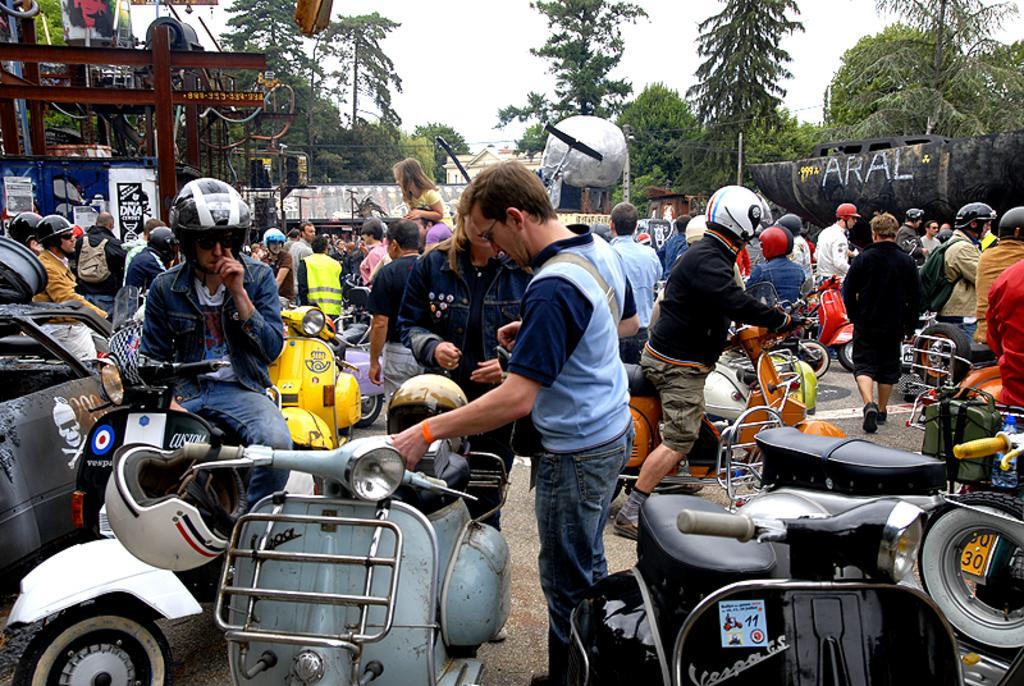Please provide a concise description of this image. This is the picture of a place where we have some people on the bikes and some other people standing and there are some trees, plants, transformers and some other things and also we can see the sky. 